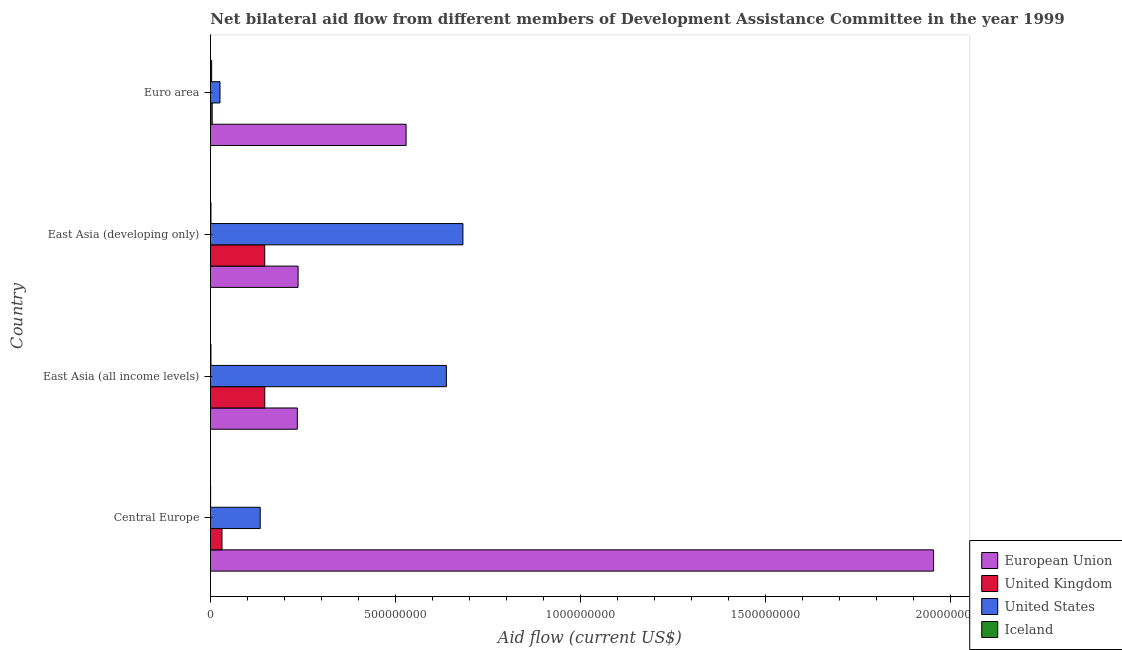Are the number of bars on each tick of the Y-axis equal?
Your answer should be very brief. Yes. How many bars are there on the 3rd tick from the bottom?
Provide a short and direct response. 4. What is the label of the 3rd group of bars from the top?
Your response must be concise. East Asia (all income levels). What is the amount of aid given by uk in East Asia (developing only)?
Your response must be concise. 1.47e+08. Across all countries, what is the maximum amount of aid given by uk?
Make the answer very short. 1.47e+08. Across all countries, what is the minimum amount of aid given by uk?
Provide a succinct answer. 4.65e+06. In which country was the amount of aid given by eu minimum?
Provide a short and direct response. East Asia (all income levels). What is the total amount of aid given by iceland in the graph?
Give a very brief answer. 6.27e+06. What is the difference between the amount of aid given by eu in Central Europe and that in East Asia (all income levels)?
Make the answer very short. 1.72e+09. What is the difference between the amount of aid given by uk in Central Europe and the amount of aid given by eu in East Asia (all income levels)?
Offer a terse response. -2.04e+08. What is the average amount of aid given by iceland per country?
Keep it short and to the point. 1.57e+06. What is the difference between the amount of aid given by iceland and amount of aid given by uk in Euro area?
Your answer should be very brief. -1.47e+06. What is the ratio of the amount of aid given by eu in Central Europe to that in East Asia (developing only)?
Offer a terse response. 8.25. Is the amount of aid given by iceland in Central Europe less than that in East Asia (all income levels)?
Offer a terse response. Yes. Is the difference between the amount of aid given by uk in East Asia (all income levels) and Euro area greater than the difference between the amount of aid given by us in East Asia (all income levels) and Euro area?
Your response must be concise. No. What is the difference between the highest and the second highest amount of aid given by eu?
Your response must be concise. 1.42e+09. What is the difference between the highest and the lowest amount of aid given by uk?
Your answer should be very brief. 1.42e+08. In how many countries, is the amount of aid given by eu greater than the average amount of aid given by eu taken over all countries?
Your response must be concise. 1. Is the sum of the amount of aid given by uk in Central Europe and Euro area greater than the maximum amount of aid given by us across all countries?
Offer a very short reply. No. Is it the case that in every country, the sum of the amount of aid given by uk and amount of aid given by iceland is greater than the sum of amount of aid given by eu and amount of aid given by us?
Ensure brevity in your answer.  No. What does the 4th bar from the bottom in Central Europe represents?
Keep it short and to the point. Iceland. Is it the case that in every country, the sum of the amount of aid given by eu and amount of aid given by uk is greater than the amount of aid given by us?
Give a very brief answer. No. How many bars are there?
Provide a succinct answer. 16. Are all the bars in the graph horizontal?
Your answer should be compact. Yes. Does the graph contain any zero values?
Make the answer very short. No. How are the legend labels stacked?
Your response must be concise. Vertical. What is the title of the graph?
Provide a succinct answer. Net bilateral aid flow from different members of Development Assistance Committee in the year 1999. Does "Negligence towards children" appear as one of the legend labels in the graph?
Provide a succinct answer. No. What is the label or title of the X-axis?
Provide a succinct answer. Aid flow (current US$). What is the label or title of the Y-axis?
Ensure brevity in your answer.  Country. What is the Aid flow (current US$) in European Union in Central Europe?
Ensure brevity in your answer.  1.95e+09. What is the Aid flow (current US$) of United Kingdom in Central Europe?
Your response must be concise. 3.10e+07. What is the Aid flow (current US$) of United States in Central Europe?
Your response must be concise. 1.34e+08. What is the Aid flow (current US$) in European Union in East Asia (all income levels)?
Ensure brevity in your answer.  2.35e+08. What is the Aid flow (current US$) of United Kingdom in East Asia (all income levels)?
Give a very brief answer. 1.47e+08. What is the Aid flow (current US$) of United States in East Asia (all income levels)?
Your answer should be compact. 6.37e+08. What is the Aid flow (current US$) of Iceland in East Asia (all income levels)?
Give a very brief answer. 1.33e+06. What is the Aid flow (current US$) of European Union in East Asia (developing only)?
Give a very brief answer. 2.37e+08. What is the Aid flow (current US$) in United Kingdom in East Asia (developing only)?
Your answer should be compact. 1.47e+08. What is the Aid flow (current US$) of United States in East Asia (developing only)?
Give a very brief answer. 6.82e+08. What is the Aid flow (current US$) in Iceland in East Asia (developing only)?
Ensure brevity in your answer.  1.33e+06. What is the Aid flow (current US$) of European Union in Euro area?
Provide a succinct answer. 5.28e+08. What is the Aid flow (current US$) of United Kingdom in Euro area?
Ensure brevity in your answer.  4.65e+06. What is the Aid flow (current US$) in United States in Euro area?
Ensure brevity in your answer.  2.57e+07. What is the Aid flow (current US$) of Iceland in Euro area?
Provide a succinct answer. 3.18e+06. Across all countries, what is the maximum Aid flow (current US$) of European Union?
Your answer should be very brief. 1.95e+09. Across all countries, what is the maximum Aid flow (current US$) in United Kingdom?
Give a very brief answer. 1.47e+08. Across all countries, what is the maximum Aid flow (current US$) of United States?
Provide a succinct answer. 6.82e+08. Across all countries, what is the maximum Aid flow (current US$) in Iceland?
Give a very brief answer. 3.18e+06. Across all countries, what is the minimum Aid flow (current US$) in European Union?
Your answer should be very brief. 2.35e+08. Across all countries, what is the minimum Aid flow (current US$) of United Kingdom?
Make the answer very short. 4.65e+06. Across all countries, what is the minimum Aid flow (current US$) in United States?
Ensure brevity in your answer.  2.57e+07. Across all countries, what is the minimum Aid flow (current US$) in Iceland?
Keep it short and to the point. 4.30e+05. What is the total Aid flow (current US$) of European Union in the graph?
Ensure brevity in your answer.  2.95e+09. What is the total Aid flow (current US$) in United Kingdom in the graph?
Provide a succinct answer. 3.29e+08. What is the total Aid flow (current US$) of United States in the graph?
Provide a short and direct response. 1.48e+09. What is the total Aid flow (current US$) in Iceland in the graph?
Your answer should be very brief. 6.27e+06. What is the difference between the Aid flow (current US$) in European Union in Central Europe and that in East Asia (all income levels)?
Provide a succinct answer. 1.72e+09. What is the difference between the Aid flow (current US$) of United Kingdom in Central Europe and that in East Asia (all income levels)?
Provide a succinct answer. -1.16e+08. What is the difference between the Aid flow (current US$) in United States in Central Europe and that in East Asia (all income levels)?
Keep it short and to the point. -5.03e+08. What is the difference between the Aid flow (current US$) of Iceland in Central Europe and that in East Asia (all income levels)?
Make the answer very short. -9.00e+05. What is the difference between the Aid flow (current US$) in European Union in Central Europe and that in East Asia (developing only)?
Your answer should be very brief. 1.72e+09. What is the difference between the Aid flow (current US$) of United Kingdom in Central Europe and that in East Asia (developing only)?
Offer a terse response. -1.16e+08. What is the difference between the Aid flow (current US$) of United States in Central Europe and that in East Asia (developing only)?
Your answer should be very brief. -5.48e+08. What is the difference between the Aid flow (current US$) in Iceland in Central Europe and that in East Asia (developing only)?
Your answer should be very brief. -9.00e+05. What is the difference between the Aid flow (current US$) of European Union in Central Europe and that in Euro area?
Offer a very short reply. 1.42e+09. What is the difference between the Aid flow (current US$) of United Kingdom in Central Europe and that in Euro area?
Provide a short and direct response. 2.64e+07. What is the difference between the Aid flow (current US$) of United States in Central Europe and that in Euro area?
Provide a short and direct response. 1.09e+08. What is the difference between the Aid flow (current US$) in Iceland in Central Europe and that in Euro area?
Keep it short and to the point. -2.75e+06. What is the difference between the Aid flow (current US$) in European Union in East Asia (all income levels) and that in East Asia (developing only)?
Your answer should be compact. -2.13e+06. What is the difference between the Aid flow (current US$) in United States in East Asia (all income levels) and that in East Asia (developing only)?
Offer a terse response. -4.47e+07. What is the difference between the Aid flow (current US$) of Iceland in East Asia (all income levels) and that in East Asia (developing only)?
Give a very brief answer. 0. What is the difference between the Aid flow (current US$) in European Union in East Asia (all income levels) and that in Euro area?
Your response must be concise. -2.94e+08. What is the difference between the Aid flow (current US$) of United Kingdom in East Asia (all income levels) and that in Euro area?
Offer a very short reply. 1.42e+08. What is the difference between the Aid flow (current US$) in United States in East Asia (all income levels) and that in Euro area?
Give a very brief answer. 6.12e+08. What is the difference between the Aid flow (current US$) in Iceland in East Asia (all income levels) and that in Euro area?
Your response must be concise. -1.85e+06. What is the difference between the Aid flow (current US$) in European Union in East Asia (developing only) and that in Euro area?
Provide a short and direct response. -2.92e+08. What is the difference between the Aid flow (current US$) of United Kingdom in East Asia (developing only) and that in Euro area?
Offer a very short reply. 1.42e+08. What is the difference between the Aid flow (current US$) in United States in East Asia (developing only) and that in Euro area?
Offer a very short reply. 6.56e+08. What is the difference between the Aid flow (current US$) in Iceland in East Asia (developing only) and that in Euro area?
Your answer should be very brief. -1.85e+06. What is the difference between the Aid flow (current US$) in European Union in Central Europe and the Aid flow (current US$) in United Kingdom in East Asia (all income levels)?
Your answer should be compact. 1.81e+09. What is the difference between the Aid flow (current US$) in European Union in Central Europe and the Aid flow (current US$) in United States in East Asia (all income levels)?
Provide a succinct answer. 1.32e+09. What is the difference between the Aid flow (current US$) in European Union in Central Europe and the Aid flow (current US$) in Iceland in East Asia (all income levels)?
Make the answer very short. 1.95e+09. What is the difference between the Aid flow (current US$) in United Kingdom in Central Europe and the Aid flow (current US$) in United States in East Asia (all income levels)?
Your answer should be very brief. -6.06e+08. What is the difference between the Aid flow (current US$) in United Kingdom in Central Europe and the Aid flow (current US$) in Iceland in East Asia (all income levels)?
Your response must be concise. 2.97e+07. What is the difference between the Aid flow (current US$) of United States in Central Europe and the Aid flow (current US$) of Iceland in East Asia (all income levels)?
Make the answer very short. 1.33e+08. What is the difference between the Aid flow (current US$) of European Union in Central Europe and the Aid flow (current US$) of United Kingdom in East Asia (developing only)?
Your answer should be compact. 1.81e+09. What is the difference between the Aid flow (current US$) in European Union in Central Europe and the Aid flow (current US$) in United States in East Asia (developing only)?
Provide a short and direct response. 1.27e+09. What is the difference between the Aid flow (current US$) of European Union in Central Europe and the Aid flow (current US$) of Iceland in East Asia (developing only)?
Your response must be concise. 1.95e+09. What is the difference between the Aid flow (current US$) of United Kingdom in Central Europe and the Aid flow (current US$) of United States in East Asia (developing only)?
Provide a succinct answer. -6.51e+08. What is the difference between the Aid flow (current US$) in United Kingdom in Central Europe and the Aid flow (current US$) in Iceland in East Asia (developing only)?
Ensure brevity in your answer.  2.97e+07. What is the difference between the Aid flow (current US$) in United States in Central Europe and the Aid flow (current US$) in Iceland in East Asia (developing only)?
Give a very brief answer. 1.33e+08. What is the difference between the Aid flow (current US$) of European Union in Central Europe and the Aid flow (current US$) of United Kingdom in Euro area?
Your answer should be compact. 1.95e+09. What is the difference between the Aid flow (current US$) of European Union in Central Europe and the Aid flow (current US$) of United States in Euro area?
Provide a short and direct response. 1.93e+09. What is the difference between the Aid flow (current US$) of European Union in Central Europe and the Aid flow (current US$) of Iceland in Euro area?
Your response must be concise. 1.95e+09. What is the difference between the Aid flow (current US$) in United Kingdom in Central Europe and the Aid flow (current US$) in United States in Euro area?
Your answer should be compact. 5.32e+06. What is the difference between the Aid flow (current US$) of United Kingdom in Central Europe and the Aid flow (current US$) of Iceland in Euro area?
Your answer should be compact. 2.79e+07. What is the difference between the Aid flow (current US$) of United States in Central Europe and the Aid flow (current US$) of Iceland in Euro area?
Offer a terse response. 1.31e+08. What is the difference between the Aid flow (current US$) of European Union in East Asia (all income levels) and the Aid flow (current US$) of United Kingdom in East Asia (developing only)?
Your answer should be very brief. 8.80e+07. What is the difference between the Aid flow (current US$) of European Union in East Asia (all income levels) and the Aid flow (current US$) of United States in East Asia (developing only)?
Provide a short and direct response. -4.47e+08. What is the difference between the Aid flow (current US$) in European Union in East Asia (all income levels) and the Aid flow (current US$) in Iceland in East Asia (developing only)?
Your response must be concise. 2.33e+08. What is the difference between the Aid flow (current US$) in United Kingdom in East Asia (all income levels) and the Aid flow (current US$) in United States in East Asia (developing only)?
Provide a succinct answer. -5.35e+08. What is the difference between the Aid flow (current US$) of United Kingdom in East Asia (all income levels) and the Aid flow (current US$) of Iceland in East Asia (developing only)?
Offer a terse response. 1.45e+08. What is the difference between the Aid flow (current US$) in United States in East Asia (all income levels) and the Aid flow (current US$) in Iceland in East Asia (developing only)?
Give a very brief answer. 6.36e+08. What is the difference between the Aid flow (current US$) of European Union in East Asia (all income levels) and the Aid flow (current US$) of United Kingdom in Euro area?
Offer a very short reply. 2.30e+08. What is the difference between the Aid flow (current US$) in European Union in East Asia (all income levels) and the Aid flow (current US$) in United States in Euro area?
Keep it short and to the point. 2.09e+08. What is the difference between the Aid flow (current US$) of European Union in East Asia (all income levels) and the Aid flow (current US$) of Iceland in Euro area?
Make the answer very short. 2.31e+08. What is the difference between the Aid flow (current US$) in United Kingdom in East Asia (all income levels) and the Aid flow (current US$) in United States in Euro area?
Your response must be concise. 1.21e+08. What is the difference between the Aid flow (current US$) of United Kingdom in East Asia (all income levels) and the Aid flow (current US$) of Iceland in Euro area?
Make the answer very short. 1.44e+08. What is the difference between the Aid flow (current US$) in United States in East Asia (all income levels) and the Aid flow (current US$) in Iceland in Euro area?
Your answer should be very brief. 6.34e+08. What is the difference between the Aid flow (current US$) of European Union in East Asia (developing only) and the Aid flow (current US$) of United Kingdom in Euro area?
Keep it short and to the point. 2.32e+08. What is the difference between the Aid flow (current US$) in European Union in East Asia (developing only) and the Aid flow (current US$) in United States in Euro area?
Give a very brief answer. 2.11e+08. What is the difference between the Aid flow (current US$) in European Union in East Asia (developing only) and the Aid flow (current US$) in Iceland in Euro area?
Your answer should be compact. 2.34e+08. What is the difference between the Aid flow (current US$) of United Kingdom in East Asia (developing only) and the Aid flow (current US$) of United States in Euro area?
Keep it short and to the point. 1.21e+08. What is the difference between the Aid flow (current US$) of United Kingdom in East Asia (developing only) and the Aid flow (current US$) of Iceland in Euro area?
Provide a short and direct response. 1.43e+08. What is the difference between the Aid flow (current US$) of United States in East Asia (developing only) and the Aid flow (current US$) of Iceland in Euro area?
Offer a very short reply. 6.79e+08. What is the average Aid flow (current US$) of European Union per country?
Your response must be concise. 7.38e+08. What is the average Aid flow (current US$) of United Kingdom per country?
Keep it short and to the point. 8.22e+07. What is the average Aid flow (current US$) of United States per country?
Your response must be concise. 3.70e+08. What is the average Aid flow (current US$) of Iceland per country?
Make the answer very short. 1.57e+06. What is the difference between the Aid flow (current US$) of European Union and Aid flow (current US$) of United Kingdom in Central Europe?
Give a very brief answer. 1.92e+09. What is the difference between the Aid flow (current US$) of European Union and Aid flow (current US$) of United States in Central Europe?
Keep it short and to the point. 1.82e+09. What is the difference between the Aid flow (current US$) in European Union and Aid flow (current US$) in Iceland in Central Europe?
Your response must be concise. 1.95e+09. What is the difference between the Aid flow (current US$) in United Kingdom and Aid flow (current US$) in United States in Central Europe?
Your answer should be compact. -1.03e+08. What is the difference between the Aid flow (current US$) in United Kingdom and Aid flow (current US$) in Iceland in Central Europe?
Provide a succinct answer. 3.06e+07. What is the difference between the Aid flow (current US$) in United States and Aid flow (current US$) in Iceland in Central Europe?
Provide a short and direct response. 1.34e+08. What is the difference between the Aid flow (current US$) of European Union and Aid flow (current US$) of United Kingdom in East Asia (all income levels)?
Offer a very short reply. 8.79e+07. What is the difference between the Aid flow (current US$) in European Union and Aid flow (current US$) in United States in East Asia (all income levels)?
Make the answer very short. -4.03e+08. What is the difference between the Aid flow (current US$) of European Union and Aid flow (current US$) of Iceland in East Asia (all income levels)?
Provide a short and direct response. 2.33e+08. What is the difference between the Aid flow (current US$) in United Kingdom and Aid flow (current US$) in United States in East Asia (all income levels)?
Offer a very short reply. -4.91e+08. What is the difference between the Aid flow (current US$) of United Kingdom and Aid flow (current US$) of Iceland in East Asia (all income levels)?
Your answer should be very brief. 1.45e+08. What is the difference between the Aid flow (current US$) of United States and Aid flow (current US$) of Iceland in East Asia (all income levels)?
Your answer should be compact. 6.36e+08. What is the difference between the Aid flow (current US$) of European Union and Aid flow (current US$) of United Kingdom in East Asia (developing only)?
Your response must be concise. 9.02e+07. What is the difference between the Aid flow (current US$) in European Union and Aid flow (current US$) in United States in East Asia (developing only)?
Offer a terse response. -4.45e+08. What is the difference between the Aid flow (current US$) of European Union and Aid flow (current US$) of Iceland in East Asia (developing only)?
Offer a very short reply. 2.35e+08. What is the difference between the Aid flow (current US$) of United Kingdom and Aid flow (current US$) of United States in East Asia (developing only)?
Your response must be concise. -5.35e+08. What is the difference between the Aid flow (current US$) of United Kingdom and Aid flow (current US$) of Iceland in East Asia (developing only)?
Keep it short and to the point. 1.45e+08. What is the difference between the Aid flow (current US$) of United States and Aid flow (current US$) of Iceland in East Asia (developing only)?
Provide a short and direct response. 6.81e+08. What is the difference between the Aid flow (current US$) of European Union and Aid flow (current US$) of United Kingdom in Euro area?
Give a very brief answer. 5.24e+08. What is the difference between the Aid flow (current US$) of European Union and Aid flow (current US$) of United States in Euro area?
Provide a short and direct response. 5.03e+08. What is the difference between the Aid flow (current US$) in European Union and Aid flow (current US$) in Iceland in Euro area?
Offer a very short reply. 5.25e+08. What is the difference between the Aid flow (current US$) in United Kingdom and Aid flow (current US$) in United States in Euro area?
Provide a short and direct response. -2.11e+07. What is the difference between the Aid flow (current US$) of United Kingdom and Aid flow (current US$) of Iceland in Euro area?
Offer a terse response. 1.47e+06. What is the difference between the Aid flow (current US$) in United States and Aid flow (current US$) in Iceland in Euro area?
Offer a terse response. 2.25e+07. What is the ratio of the Aid flow (current US$) in European Union in Central Europe to that in East Asia (all income levels)?
Provide a succinct answer. 8.33. What is the ratio of the Aid flow (current US$) of United Kingdom in Central Europe to that in East Asia (all income levels)?
Your answer should be very brief. 0.21. What is the ratio of the Aid flow (current US$) of United States in Central Europe to that in East Asia (all income levels)?
Make the answer very short. 0.21. What is the ratio of the Aid flow (current US$) of Iceland in Central Europe to that in East Asia (all income levels)?
Provide a short and direct response. 0.32. What is the ratio of the Aid flow (current US$) in European Union in Central Europe to that in East Asia (developing only)?
Offer a very short reply. 8.25. What is the ratio of the Aid flow (current US$) in United Kingdom in Central Europe to that in East Asia (developing only)?
Your response must be concise. 0.21. What is the ratio of the Aid flow (current US$) of United States in Central Europe to that in East Asia (developing only)?
Offer a very short reply. 0.2. What is the ratio of the Aid flow (current US$) in Iceland in Central Europe to that in East Asia (developing only)?
Offer a very short reply. 0.32. What is the ratio of the Aid flow (current US$) of European Union in Central Europe to that in Euro area?
Your answer should be very brief. 3.7. What is the ratio of the Aid flow (current US$) in United Kingdom in Central Europe to that in Euro area?
Your answer should be very brief. 6.68. What is the ratio of the Aid flow (current US$) in United States in Central Europe to that in Euro area?
Give a very brief answer. 5.23. What is the ratio of the Aid flow (current US$) of Iceland in Central Europe to that in Euro area?
Give a very brief answer. 0.14. What is the ratio of the Aid flow (current US$) of European Union in East Asia (all income levels) to that in East Asia (developing only)?
Your answer should be compact. 0.99. What is the ratio of the Aid flow (current US$) of United Kingdom in East Asia (all income levels) to that in East Asia (developing only)?
Provide a succinct answer. 1. What is the ratio of the Aid flow (current US$) of United States in East Asia (all income levels) to that in East Asia (developing only)?
Keep it short and to the point. 0.93. What is the ratio of the Aid flow (current US$) in Iceland in East Asia (all income levels) to that in East Asia (developing only)?
Offer a terse response. 1. What is the ratio of the Aid flow (current US$) of European Union in East Asia (all income levels) to that in Euro area?
Make the answer very short. 0.44. What is the ratio of the Aid flow (current US$) of United Kingdom in East Asia (all income levels) to that in Euro area?
Make the answer very short. 31.54. What is the ratio of the Aid flow (current US$) of United States in East Asia (all income levels) to that in Euro area?
Your answer should be very brief. 24.78. What is the ratio of the Aid flow (current US$) of Iceland in East Asia (all income levels) to that in Euro area?
Your answer should be very brief. 0.42. What is the ratio of the Aid flow (current US$) in European Union in East Asia (developing only) to that in Euro area?
Your answer should be very brief. 0.45. What is the ratio of the Aid flow (current US$) of United Kingdom in East Asia (developing only) to that in Euro area?
Provide a short and direct response. 31.52. What is the ratio of the Aid flow (current US$) of United States in East Asia (developing only) to that in Euro area?
Your answer should be compact. 26.52. What is the ratio of the Aid flow (current US$) of Iceland in East Asia (developing only) to that in Euro area?
Provide a short and direct response. 0.42. What is the difference between the highest and the second highest Aid flow (current US$) in European Union?
Offer a very short reply. 1.42e+09. What is the difference between the highest and the second highest Aid flow (current US$) of United Kingdom?
Make the answer very short. 1.30e+05. What is the difference between the highest and the second highest Aid flow (current US$) in United States?
Ensure brevity in your answer.  4.47e+07. What is the difference between the highest and the second highest Aid flow (current US$) of Iceland?
Your answer should be very brief. 1.85e+06. What is the difference between the highest and the lowest Aid flow (current US$) in European Union?
Provide a short and direct response. 1.72e+09. What is the difference between the highest and the lowest Aid flow (current US$) of United Kingdom?
Give a very brief answer. 1.42e+08. What is the difference between the highest and the lowest Aid flow (current US$) of United States?
Ensure brevity in your answer.  6.56e+08. What is the difference between the highest and the lowest Aid flow (current US$) of Iceland?
Keep it short and to the point. 2.75e+06. 